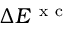Convert formula to latex. <formula><loc_0><loc_0><loc_500><loc_500>\Delta E ^ { x c }</formula> 